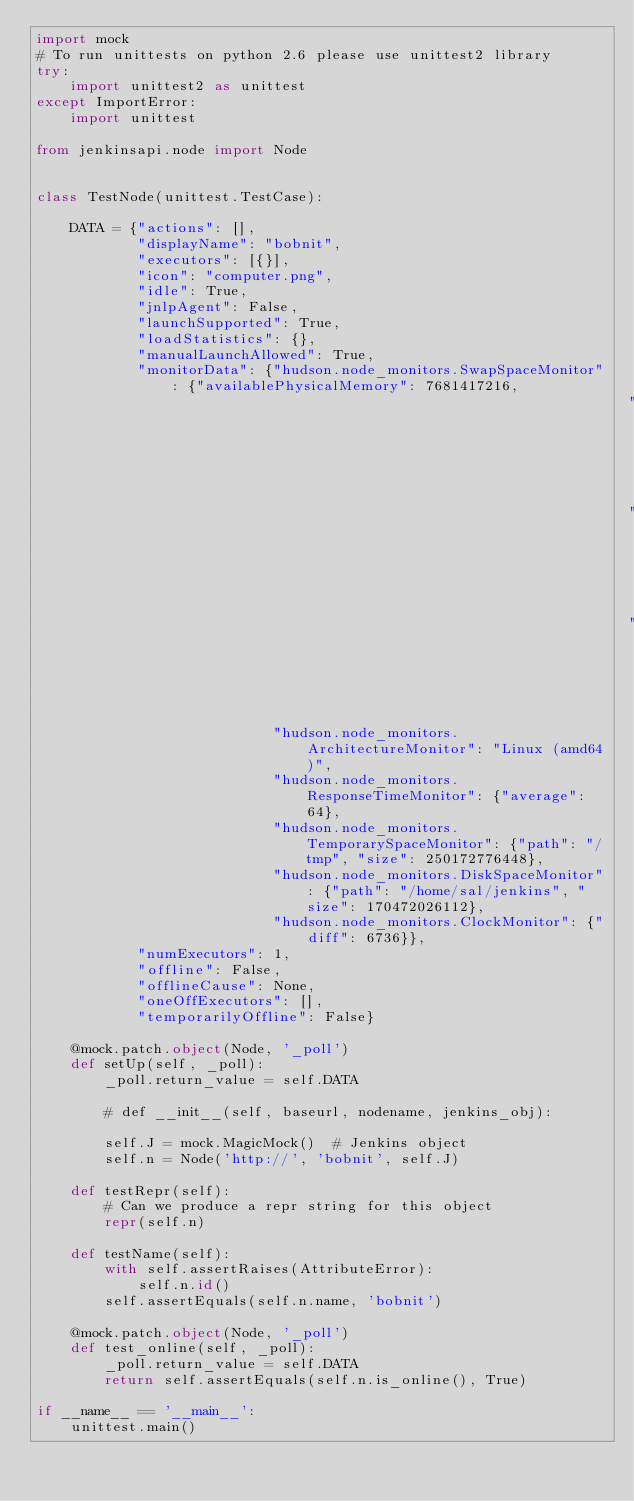Convert code to text. <code><loc_0><loc_0><loc_500><loc_500><_Python_>import mock
# To run unittests on python 2.6 please use unittest2 library
try:
    import unittest2 as unittest
except ImportError:
    import unittest

from jenkinsapi.node import Node


class TestNode(unittest.TestCase):

    DATA = {"actions": [],
            "displayName": "bobnit",
            "executors": [{}],
            "icon": "computer.png",
            "idle": True,
            "jnlpAgent": False,
            "launchSupported": True,
            "loadStatistics": {},
            "manualLaunchAllowed": True,
            "monitorData": {"hudson.node_monitors.SwapSpaceMonitor": {"availablePhysicalMemory": 7681417216,
                                                                      "availableSwapSpace": 12195983360,
                                                                      "totalPhysicalMemory": 8374497280,
                                                                      "totalSwapSpace": 12195983360},
                            "hudson.node_monitors.ArchitectureMonitor": "Linux (amd64)",
                            "hudson.node_monitors.ResponseTimeMonitor": {"average": 64},
                            "hudson.node_monitors.TemporarySpaceMonitor": {"path": "/tmp", "size": 250172776448},
                            "hudson.node_monitors.DiskSpaceMonitor": {"path": "/home/sal/jenkins", "size": 170472026112},
                            "hudson.node_monitors.ClockMonitor": {"diff": 6736}},
            "numExecutors": 1,
            "offline": False,
            "offlineCause": None,
            "oneOffExecutors": [],
            "temporarilyOffline": False}

    @mock.patch.object(Node, '_poll')
    def setUp(self, _poll):
        _poll.return_value = self.DATA

        # def __init__(self, baseurl, nodename, jenkins_obj):

        self.J = mock.MagicMock()  # Jenkins object
        self.n = Node('http://', 'bobnit', self.J)

    def testRepr(self):
        # Can we produce a repr string for this object
        repr(self.n)

    def testName(self):
        with self.assertRaises(AttributeError):
            self.n.id()
        self.assertEquals(self.n.name, 'bobnit')

    @mock.patch.object(Node, '_poll')
    def test_online(self, _poll):
        _poll.return_value = self.DATA
        return self.assertEquals(self.n.is_online(), True)

if __name__ == '__main__':
    unittest.main()
</code> 